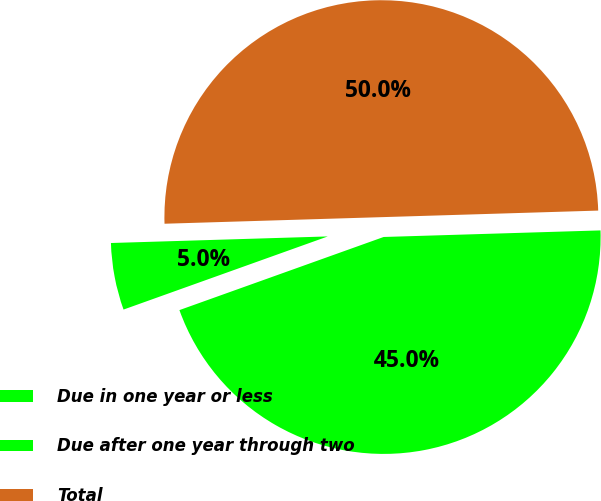<chart> <loc_0><loc_0><loc_500><loc_500><pie_chart><fcel>Due in one year or less<fcel>Due after one year through two<fcel>Total<nl><fcel>45.01%<fcel>4.99%<fcel>50.0%<nl></chart> 